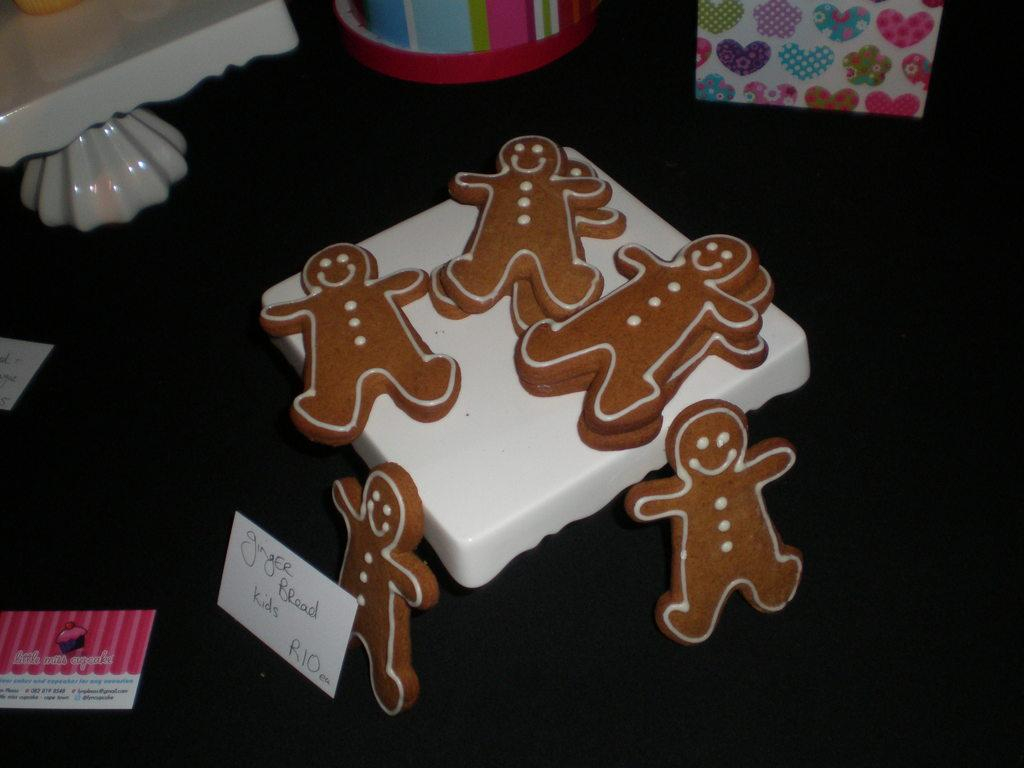What type of food item is visible in the image? The specific type of food item is not mentioned, but there is a food item in the image. What else can be seen in the image besides the food item? There are cards and a stand visible in the image. What is the surface on which the objects are placed? The objects are placed on a black surface in the image. How does the snow affect the food item in the image? There is no snow present in the image, so it cannot affect the food item. 